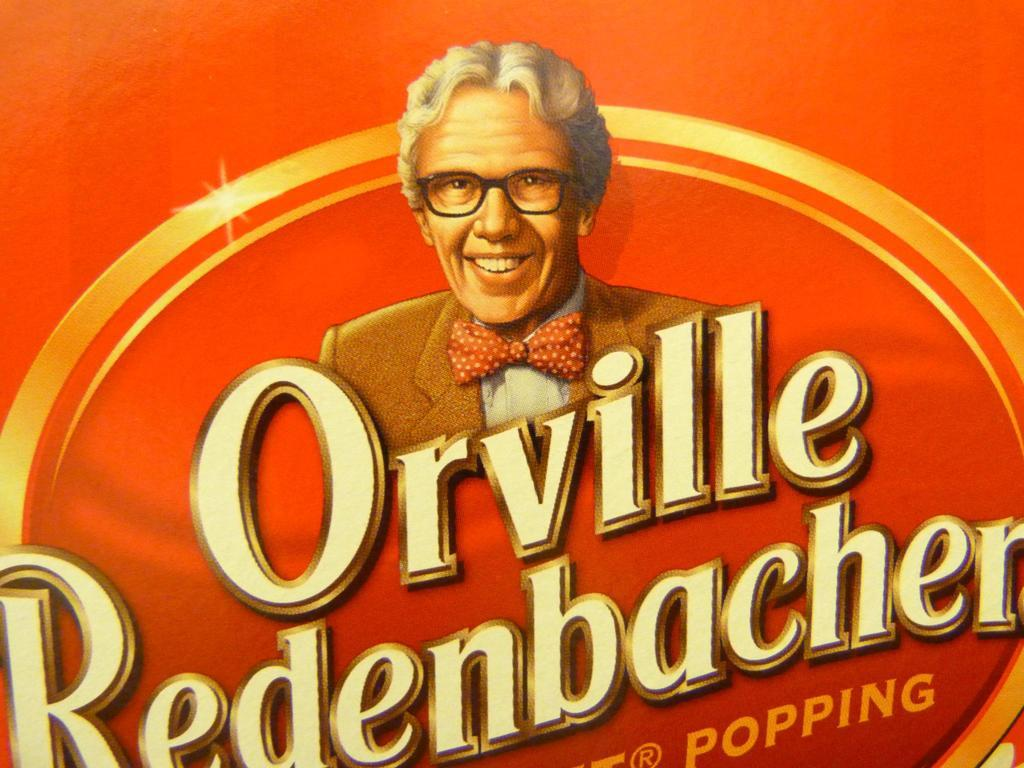What is present on the poster in the image? The poster contains text and an image. Can you describe the image on the poster? Unfortunately, the specific image on the poster cannot be described without more information. What type of content is included in the text on the poster? The content of the text on the poster cannot be determined without more information. How many bikes are parked next to the poster in the image? There is no mention of bikes in the image, so it is not possible to answer this question. 